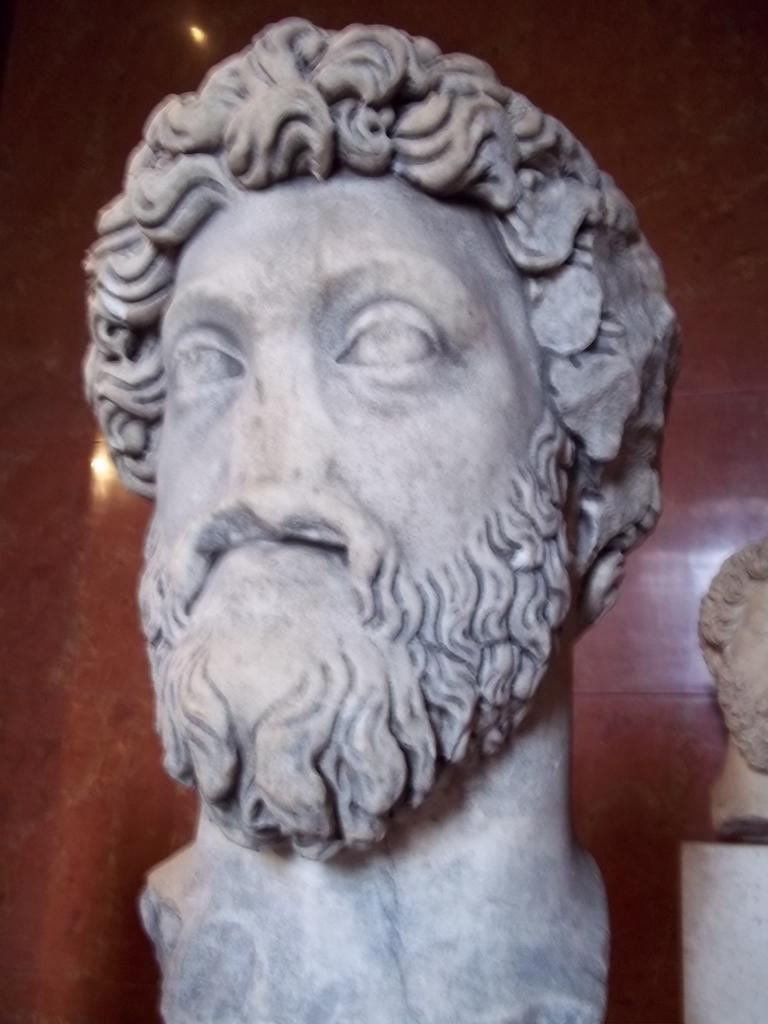What is the main subject in the image? There is a sculpture in front of the wall in the image. Are there any other sculptures visible in the image? Yes, there is another sculpture on the right side of the image. What type of hook is used to hang the veil on the sculpture? There is no hook or veil present in the image; it only features two sculptures. 